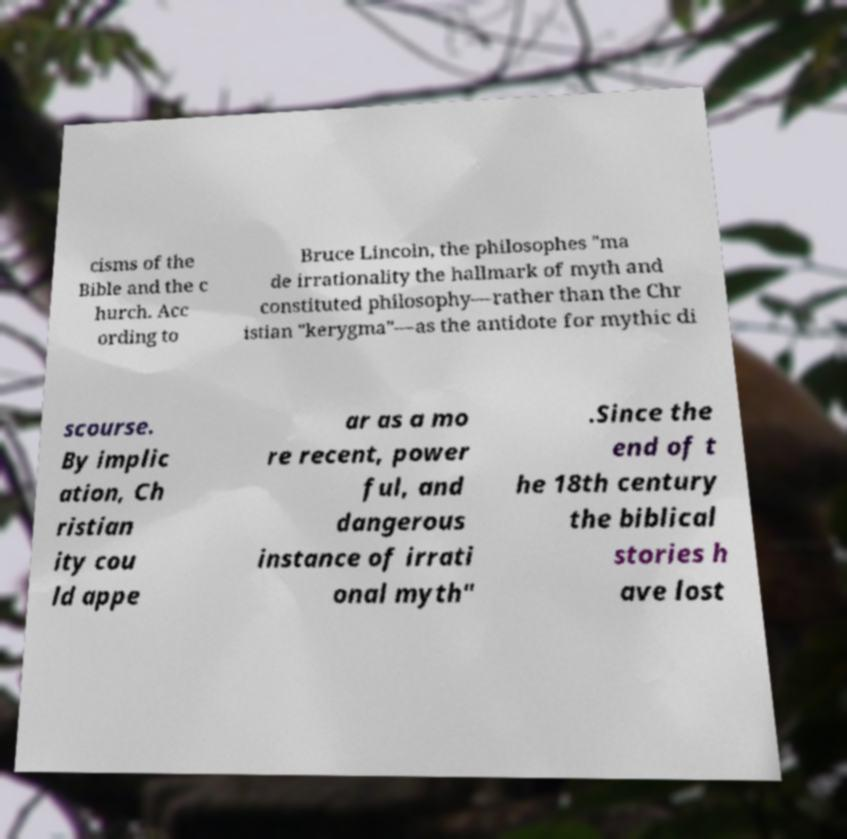I need the written content from this picture converted into text. Can you do that? cisms of the Bible and the c hurch. Acc ording to Bruce Lincoln, the philosophes "ma de irrationality the hallmark of myth and constituted philosophy—rather than the Chr istian "kerygma"—as the antidote for mythic di scourse. By implic ation, Ch ristian ity cou ld appe ar as a mo re recent, power ful, and dangerous instance of irrati onal myth" .Since the end of t he 18th century the biblical stories h ave lost 